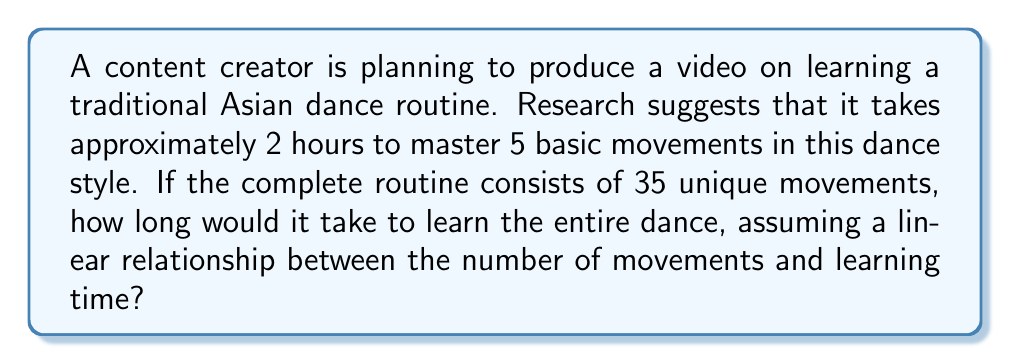Could you help me with this problem? Let's approach this step-by-step:

1) First, we need to establish the relationship between movements and time:
   5 movements = 2 hours

2) We can express this as a rate:
   $\frac{2 \text{ hours}}{5 \text{ movements}} = 0.4 \text{ hours per movement}$

3) Now we can set up a linear equation:
   Let $y$ be the time in hours and $x$ be the number of movements
   $y = 0.4x$

4) We want to find $y$ when $x = 35$:
   $y = 0.4(35)$

5) Solving this:
   $y = 14$

Therefore, it would take 14 hours to learn the entire dance routine with 35 movements.
Answer: 14 hours 